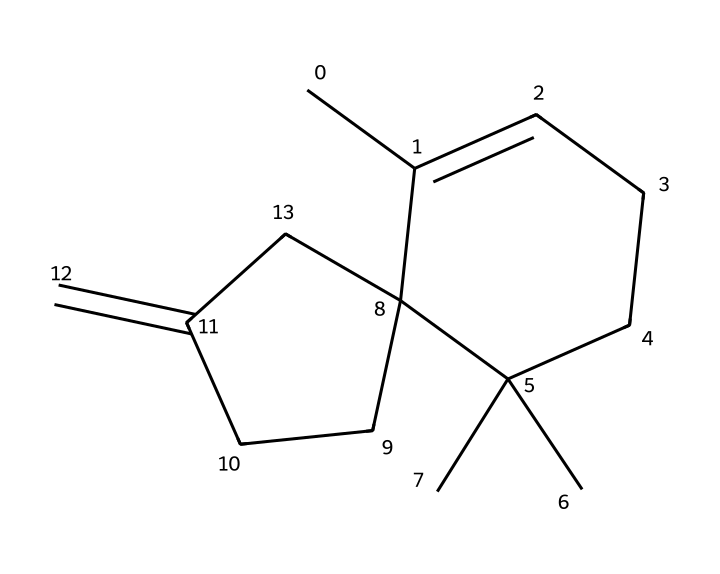How many carbon atoms are present in caryophyllene? By examining the molecular structure, we can identify each carbon atom by locating the vertices and ends of the lines representing bonds. Counting these gives us a total of 15 carbon atoms.
Answer: 15 What type of hybridization is predominantly present in the carbon atoms of caryophyllene? The carbon atoms in caryophyllene are mostly involved in forming double bonds and single bonds. This indicates that the predominant hybridization of the carbon atoms is sp2, which is typical for terpenes with unsaturation.
Answer: sp2 How many double bonds exist in caryophyllene? The structure shows that there is one double bond, as indicated by a double line between two carbon atoms. Counting this gives us a total of 1 double bond in the molecule.
Answer: 1 Is caryophyllene a cyclic compound? Observing the structure, we note that there are loops formed by the carbon atoms, indicating the presence of a cyclic arrangement, confirming it as a cyclic compound.
Answer: Yes What type of compound is caryophyllene classified as? Caryophyllene is classified as a terpene based on its structural characteristics; it is specifically a sesquiterpene, which is derived from three isoprene units.
Answer: terpene What is the molecular formula for caryophyllene? By counting the respective atoms: 15 carbons, 24 hydrogens, and no heteroatoms give the molecular formula as C15H24.
Answer: C15H24 